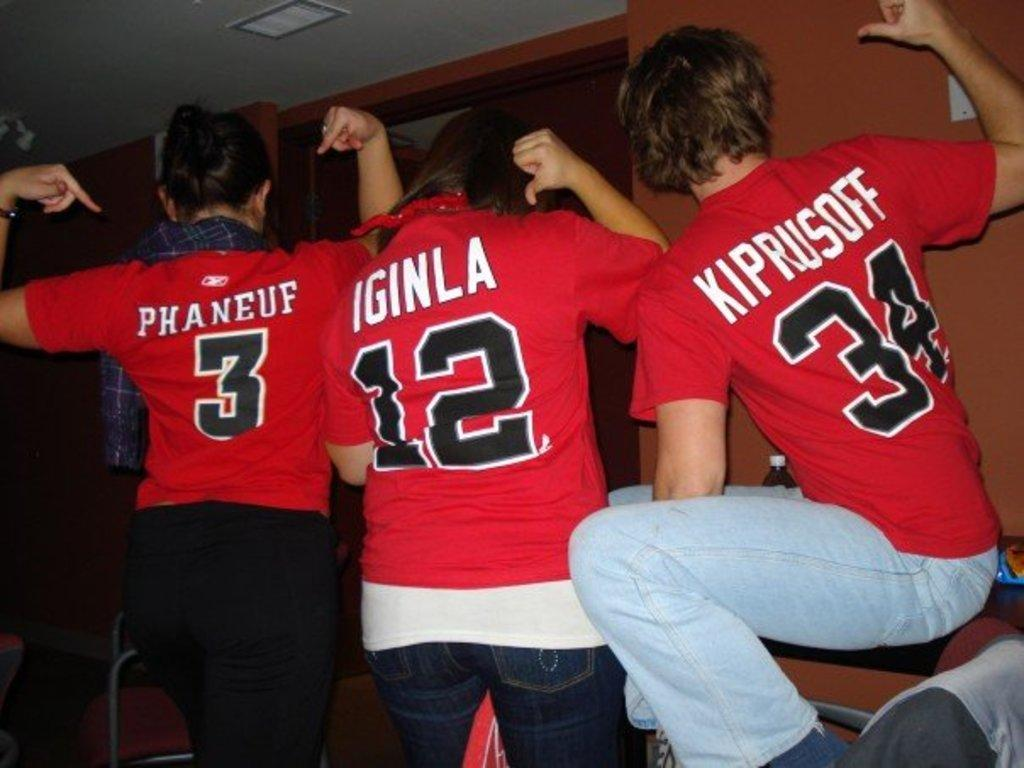<image>
Share a concise interpretation of the image provided. Three people wearing jerseys with the number 3, 12, and 34 stand together. 